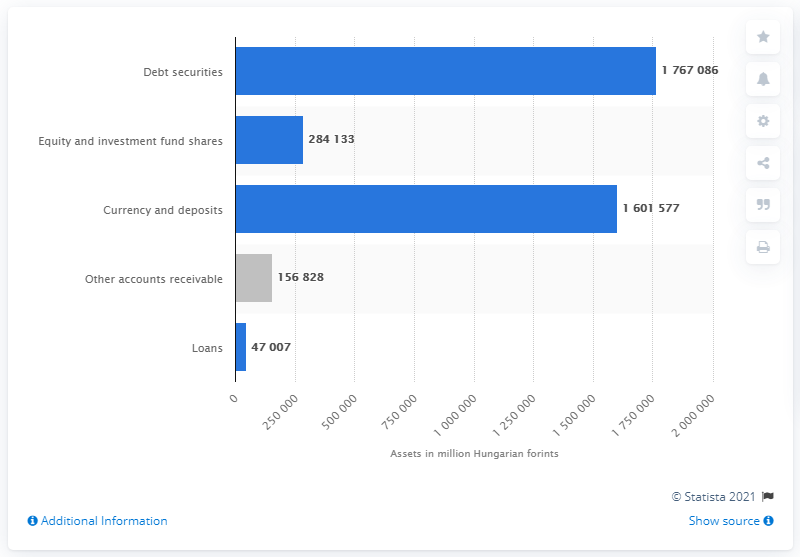Indicate a few pertinent items in this graphic. As of 2019, investment funds owned a total of 160,157,710 Hungarian forints. 